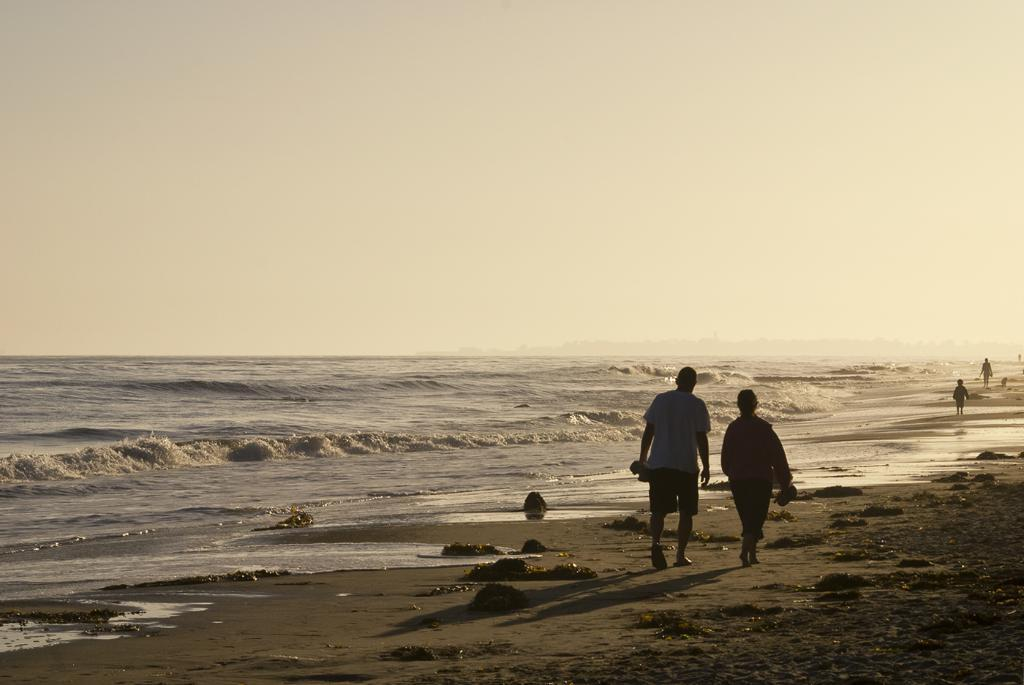What are the people in the image doing? The people in the image are walking. On what surface are the people walking? The people are walking on the ground. What natural element can be seen in the image? There is water visible in the image. What is the size of the bite taken out of the water in the image? There is no bite taken out of the water in the image; it is a natural element and not a solid object that can be bitten. 